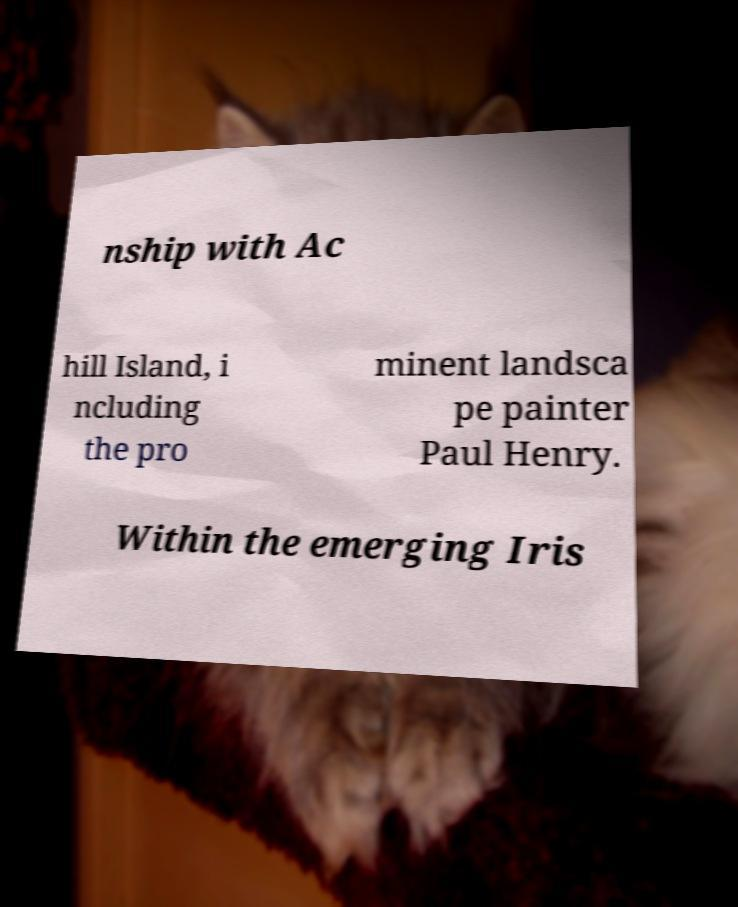Could you assist in decoding the text presented in this image and type it out clearly? nship with Ac hill Island, i ncluding the pro minent landsca pe painter Paul Henry. Within the emerging Iris 